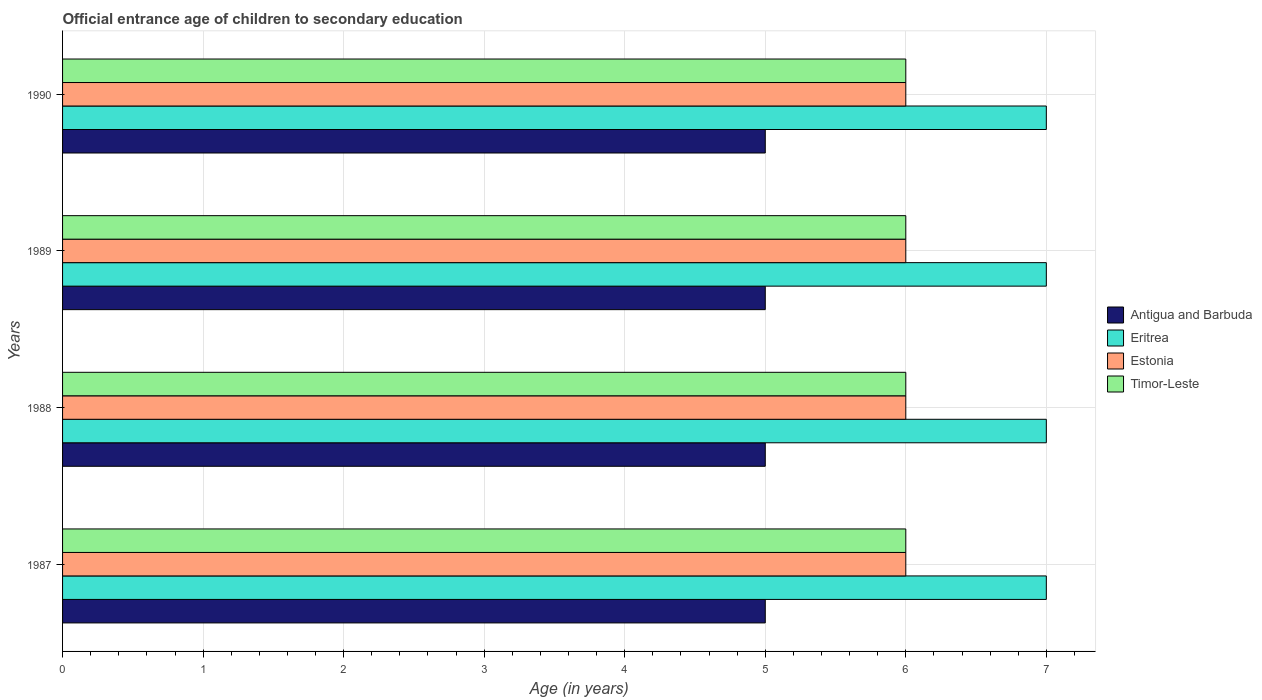Are the number of bars per tick equal to the number of legend labels?
Your answer should be very brief. Yes. How many bars are there on the 2nd tick from the top?
Your answer should be very brief. 4. How many bars are there on the 4th tick from the bottom?
Keep it short and to the point. 4. In how many cases, is the number of bars for a given year not equal to the number of legend labels?
Your answer should be compact. 0. What is the secondary school starting age of children in Antigua and Barbuda in 1989?
Offer a terse response. 5. Across all years, what is the maximum secondary school starting age of children in Timor-Leste?
Ensure brevity in your answer.  6. Across all years, what is the minimum secondary school starting age of children in Timor-Leste?
Offer a very short reply. 6. In which year was the secondary school starting age of children in Timor-Leste maximum?
Offer a very short reply. 1987. In which year was the secondary school starting age of children in Antigua and Barbuda minimum?
Your answer should be very brief. 1987. What is the total secondary school starting age of children in Timor-Leste in the graph?
Offer a very short reply. 24. What is the difference between the secondary school starting age of children in Estonia in 1987 and that in 1990?
Keep it short and to the point. 0. What is the difference between the secondary school starting age of children in Timor-Leste in 1990 and the secondary school starting age of children in Estonia in 1989?
Your response must be concise. 0. In the year 1990, what is the difference between the secondary school starting age of children in Antigua and Barbuda and secondary school starting age of children in Eritrea?
Your response must be concise. -2. In how many years, is the secondary school starting age of children in Antigua and Barbuda greater than 6 years?
Give a very brief answer. 0. What is the ratio of the secondary school starting age of children in Timor-Leste in 1987 to that in 1989?
Provide a succinct answer. 1. Is the secondary school starting age of children in Eritrea in 1987 less than that in 1988?
Keep it short and to the point. No. Is the sum of the secondary school starting age of children in Timor-Leste in 1987 and 1990 greater than the maximum secondary school starting age of children in Eritrea across all years?
Offer a terse response. Yes. What does the 1st bar from the top in 1988 represents?
Your response must be concise. Timor-Leste. What does the 3rd bar from the bottom in 1989 represents?
Your answer should be compact. Estonia. How many bars are there?
Your answer should be very brief. 16. Are the values on the major ticks of X-axis written in scientific E-notation?
Give a very brief answer. No. How many legend labels are there?
Ensure brevity in your answer.  4. How are the legend labels stacked?
Give a very brief answer. Vertical. What is the title of the graph?
Ensure brevity in your answer.  Official entrance age of children to secondary education. What is the label or title of the X-axis?
Ensure brevity in your answer.  Age (in years). What is the Age (in years) of Eritrea in 1987?
Your answer should be compact. 7. What is the Age (in years) in Estonia in 1987?
Keep it short and to the point. 6. What is the Age (in years) of Estonia in 1988?
Provide a succinct answer. 6. What is the Age (in years) in Timor-Leste in 1988?
Make the answer very short. 6. What is the Age (in years) of Eritrea in 1989?
Offer a terse response. 7. What is the Age (in years) of Estonia in 1989?
Keep it short and to the point. 6. What is the Age (in years) of Timor-Leste in 1989?
Your answer should be very brief. 6. What is the Age (in years) in Antigua and Barbuda in 1990?
Your response must be concise. 5. What is the Age (in years) of Eritrea in 1990?
Make the answer very short. 7. Across all years, what is the maximum Age (in years) in Antigua and Barbuda?
Give a very brief answer. 5. Across all years, what is the maximum Age (in years) in Estonia?
Your answer should be compact. 6. Across all years, what is the minimum Age (in years) in Estonia?
Provide a succinct answer. 6. What is the total Age (in years) in Antigua and Barbuda in the graph?
Give a very brief answer. 20. What is the total Age (in years) of Eritrea in the graph?
Ensure brevity in your answer.  28. What is the total Age (in years) of Estonia in the graph?
Your answer should be compact. 24. What is the total Age (in years) of Timor-Leste in the graph?
Your response must be concise. 24. What is the difference between the Age (in years) in Eritrea in 1987 and that in 1989?
Make the answer very short. 0. What is the difference between the Age (in years) of Timor-Leste in 1987 and that in 1989?
Offer a terse response. 0. What is the difference between the Age (in years) in Estonia in 1987 and that in 1990?
Give a very brief answer. 0. What is the difference between the Age (in years) in Antigua and Barbuda in 1988 and that in 1989?
Provide a short and direct response. 0. What is the difference between the Age (in years) of Eritrea in 1988 and that in 1989?
Keep it short and to the point. 0. What is the difference between the Age (in years) of Antigua and Barbuda in 1988 and that in 1990?
Ensure brevity in your answer.  0. What is the difference between the Age (in years) in Eritrea in 1988 and that in 1990?
Provide a short and direct response. 0. What is the difference between the Age (in years) in Estonia in 1988 and that in 1990?
Provide a succinct answer. 0. What is the difference between the Age (in years) of Estonia in 1989 and that in 1990?
Make the answer very short. 0. What is the difference between the Age (in years) of Timor-Leste in 1989 and that in 1990?
Offer a very short reply. 0. What is the difference between the Age (in years) in Antigua and Barbuda in 1987 and the Age (in years) in Eritrea in 1988?
Provide a short and direct response. -2. What is the difference between the Age (in years) of Antigua and Barbuda in 1987 and the Age (in years) of Estonia in 1988?
Ensure brevity in your answer.  -1. What is the difference between the Age (in years) of Antigua and Barbuda in 1987 and the Age (in years) of Timor-Leste in 1988?
Give a very brief answer. -1. What is the difference between the Age (in years) in Eritrea in 1987 and the Age (in years) in Timor-Leste in 1988?
Your response must be concise. 1. What is the difference between the Age (in years) of Antigua and Barbuda in 1987 and the Age (in years) of Timor-Leste in 1989?
Provide a short and direct response. -1. What is the difference between the Age (in years) of Eritrea in 1987 and the Age (in years) of Timor-Leste in 1989?
Provide a succinct answer. 1. What is the difference between the Age (in years) of Estonia in 1987 and the Age (in years) of Timor-Leste in 1989?
Your answer should be very brief. 0. What is the difference between the Age (in years) of Antigua and Barbuda in 1987 and the Age (in years) of Estonia in 1990?
Provide a short and direct response. -1. What is the difference between the Age (in years) of Antigua and Barbuda in 1987 and the Age (in years) of Timor-Leste in 1990?
Provide a succinct answer. -1. What is the difference between the Age (in years) of Eritrea in 1987 and the Age (in years) of Estonia in 1990?
Give a very brief answer. 1. What is the difference between the Age (in years) in Estonia in 1987 and the Age (in years) in Timor-Leste in 1990?
Give a very brief answer. 0. What is the difference between the Age (in years) in Antigua and Barbuda in 1988 and the Age (in years) in Eritrea in 1989?
Offer a very short reply. -2. What is the difference between the Age (in years) of Antigua and Barbuda in 1988 and the Age (in years) of Estonia in 1989?
Make the answer very short. -1. What is the difference between the Age (in years) in Antigua and Barbuda in 1988 and the Age (in years) in Timor-Leste in 1989?
Keep it short and to the point. -1. What is the difference between the Age (in years) in Eritrea in 1988 and the Age (in years) in Estonia in 1989?
Your response must be concise. 1. What is the difference between the Age (in years) of Eritrea in 1988 and the Age (in years) of Timor-Leste in 1989?
Offer a terse response. 1. What is the difference between the Age (in years) in Antigua and Barbuda in 1988 and the Age (in years) in Estonia in 1990?
Keep it short and to the point. -1. What is the difference between the Age (in years) of Eritrea in 1988 and the Age (in years) of Estonia in 1990?
Your answer should be compact. 1. What is the difference between the Age (in years) of Antigua and Barbuda in 1989 and the Age (in years) of Eritrea in 1990?
Ensure brevity in your answer.  -2. What is the difference between the Age (in years) in Antigua and Barbuda in 1989 and the Age (in years) in Estonia in 1990?
Keep it short and to the point. -1. What is the difference between the Age (in years) in Antigua and Barbuda in 1989 and the Age (in years) in Timor-Leste in 1990?
Offer a very short reply. -1. What is the average Age (in years) of Timor-Leste per year?
Keep it short and to the point. 6. In the year 1987, what is the difference between the Age (in years) of Antigua and Barbuda and Age (in years) of Timor-Leste?
Ensure brevity in your answer.  -1. In the year 1987, what is the difference between the Age (in years) in Estonia and Age (in years) in Timor-Leste?
Provide a short and direct response. 0. In the year 1988, what is the difference between the Age (in years) in Antigua and Barbuda and Age (in years) in Estonia?
Provide a succinct answer. -1. In the year 1988, what is the difference between the Age (in years) of Eritrea and Age (in years) of Estonia?
Offer a very short reply. 1. In the year 1988, what is the difference between the Age (in years) in Estonia and Age (in years) in Timor-Leste?
Your answer should be very brief. 0. In the year 1989, what is the difference between the Age (in years) in Antigua and Barbuda and Age (in years) in Estonia?
Your answer should be very brief. -1. In the year 1989, what is the difference between the Age (in years) of Antigua and Barbuda and Age (in years) of Timor-Leste?
Your answer should be compact. -1. In the year 1990, what is the difference between the Age (in years) of Antigua and Barbuda and Age (in years) of Eritrea?
Ensure brevity in your answer.  -2. In the year 1990, what is the difference between the Age (in years) of Antigua and Barbuda and Age (in years) of Estonia?
Provide a succinct answer. -1. In the year 1990, what is the difference between the Age (in years) of Eritrea and Age (in years) of Timor-Leste?
Your response must be concise. 1. In the year 1990, what is the difference between the Age (in years) of Estonia and Age (in years) of Timor-Leste?
Keep it short and to the point. 0. What is the ratio of the Age (in years) of Eritrea in 1987 to that in 1988?
Give a very brief answer. 1. What is the ratio of the Age (in years) of Timor-Leste in 1987 to that in 1988?
Give a very brief answer. 1. What is the ratio of the Age (in years) in Antigua and Barbuda in 1987 to that in 1989?
Provide a short and direct response. 1. What is the ratio of the Age (in years) in Eritrea in 1987 to that in 1989?
Your answer should be very brief. 1. What is the ratio of the Age (in years) of Timor-Leste in 1987 to that in 1990?
Keep it short and to the point. 1. What is the ratio of the Age (in years) of Estonia in 1988 to that in 1989?
Provide a short and direct response. 1. What is the ratio of the Age (in years) of Timor-Leste in 1988 to that in 1989?
Your answer should be very brief. 1. What is the ratio of the Age (in years) of Antigua and Barbuda in 1988 to that in 1990?
Ensure brevity in your answer.  1. What is the ratio of the Age (in years) of Eritrea in 1988 to that in 1990?
Your answer should be very brief. 1. What is the ratio of the Age (in years) in Antigua and Barbuda in 1989 to that in 1990?
Offer a terse response. 1. What is the ratio of the Age (in years) in Eritrea in 1989 to that in 1990?
Keep it short and to the point. 1. What is the ratio of the Age (in years) of Estonia in 1989 to that in 1990?
Ensure brevity in your answer.  1. What is the ratio of the Age (in years) in Timor-Leste in 1989 to that in 1990?
Provide a succinct answer. 1. What is the difference between the highest and the second highest Age (in years) of Eritrea?
Offer a terse response. 0. What is the difference between the highest and the second highest Age (in years) in Estonia?
Offer a terse response. 0. What is the difference between the highest and the second highest Age (in years) of Timor-Leste?
Your response must be concise. 0. 